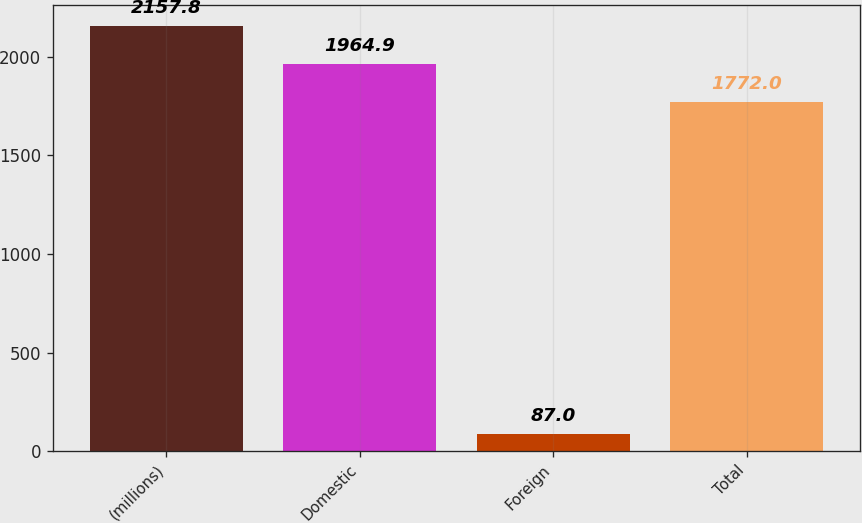Convert chart to OTSL. <chart><loc_0><loc_0><loc_500><loc_500><bar_chart><fcel>(millions)<fcel>Domestic<fcel>Foreign<fcel>Total<nl><fcel>2157.8<fcel>1964.9<fcel>87<fcel>1772<nl></chart> 